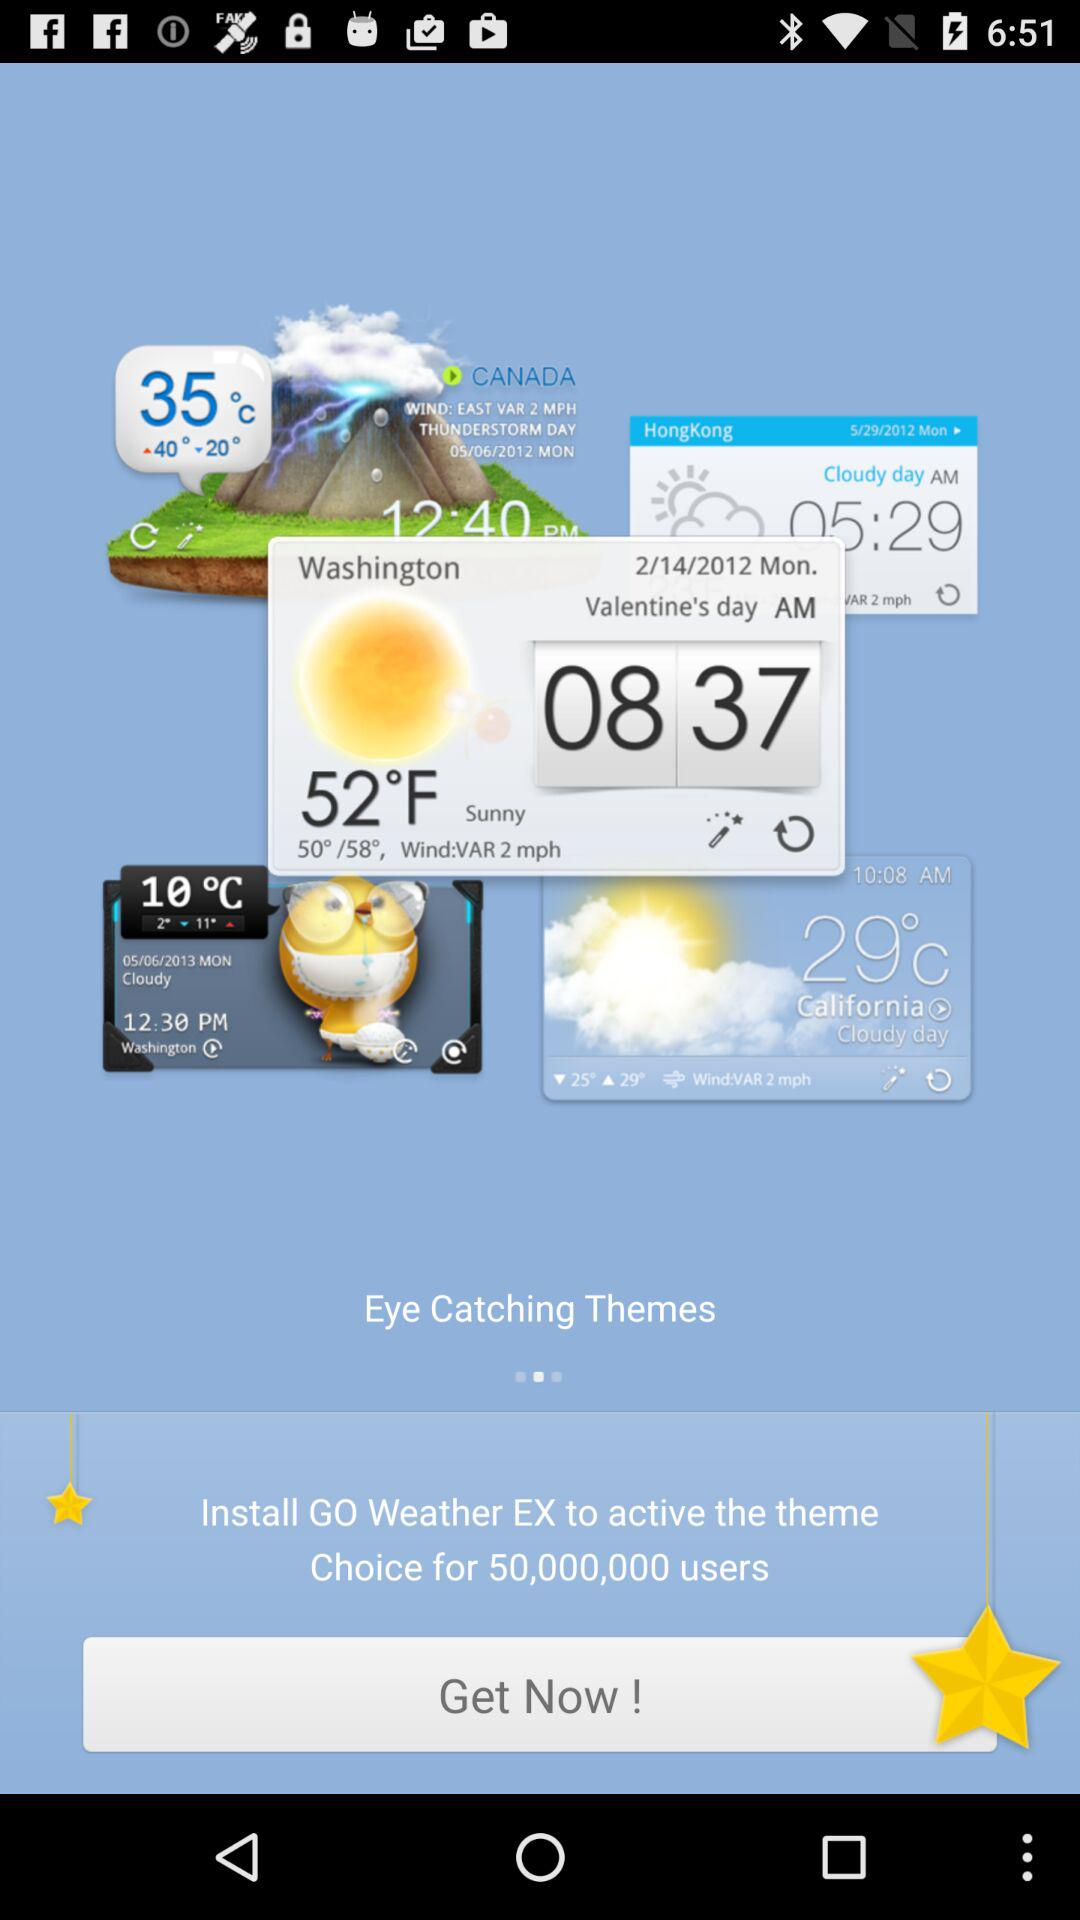Which day falls on 2/14/2012? The day is Monday. 